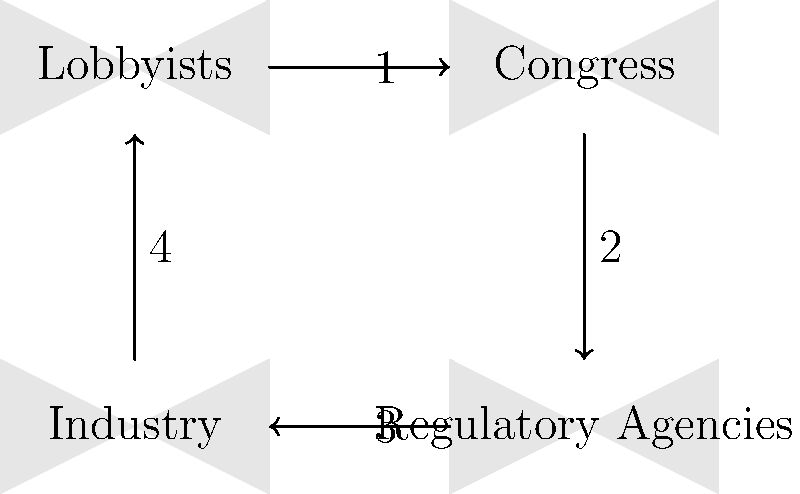In the flow diagram representing the lobbying process in the US government, which step would be most critical for ensuring that aviation industry concerns are effectively communicated to regulatory agencies without direct government intervention? To answer this question, we need to analyze the flow diagram and understand the lobbying process in the context of the aviation industry:

1. Step 1 shows lobbyists communicating with Congress.
2. Step 2 represents Congress influencing regulatory agencies.
3. Step 3 depicts regulatory agencies impacting the industry.
4. Step 4 shows the industry providing information to lobbyists.

As a lobbyist representing oil and gas companies who opposes government intervention in the aviation industry, the most critical step would be Step 1. Here's why:

1. Direct communication with Congress allows lobbyists to present industry concerns without government intervention.
2. By focusing on Step 1, lobbyists can influence legislation and policy direction before it reaches regulatory agencies.
3. This approach helps maintain industry autonomy by shaping the narrative at the legislative level.
4. It allows for proactive measures rather than reactive responses to regulatory decisions.
5. Effective communication at this stage can potentially reduce the need for stringent regulations or government interference.

By prioritizing Step 1, lobbyists can work to ensure that aviation industry concerns are addressed through legislative channels, potentially minimizing direct government intervention through regulatory agencies.
Answer: Step 1 (Lobbyists to Congress) 